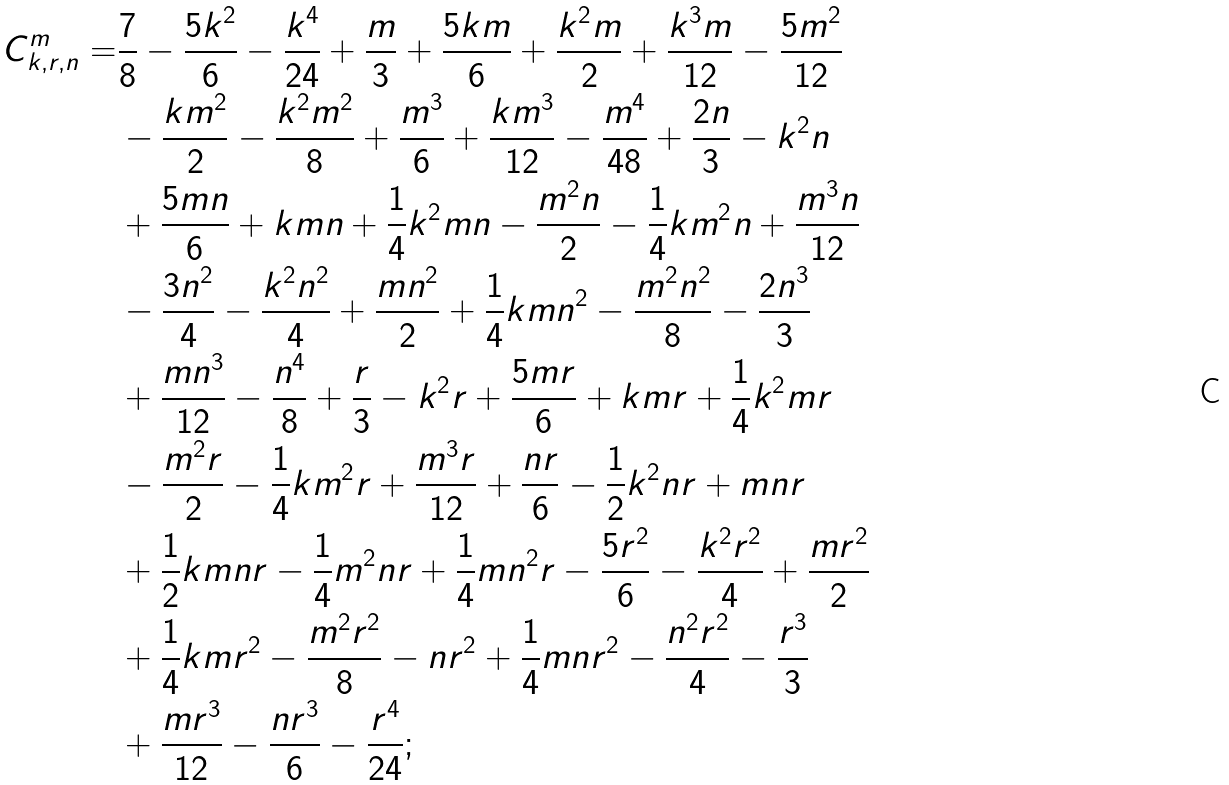<formula> <loc_0><loc_0><loc_500><loc_500>C ^ { m } _ { k , r , n } = & \frac { 7 } { 8 } - \frac { 5 k ^ { 2 } } { 6 } - \frac { k ^ { 4 } } { 2 4 } + \frac { m } { 3 } + \frac { 5 k m } { 6 } + \frac { k ^ { 2 } m } { 2 } + \frac { k ^ { 3 } m } { 1 2 } - \frac { 5 m ^ { 2 } } { 1 2 } \quad \\ & - \frac { k m ^ { 2 } } { 2 } - \frac { k ^ { 2 } m ^ { 2 } } { 8 } + \frac { m ^ { 3 } } { 6 } + \frac { k m ^ { 3 } } { 1 2 } - \frac { m ^ { 4 } } { 4 8 } + \frac { 2 n } { 3 } - k ^ { 2 } n \\ & + \frac { 5 m n } { 6 } + k m n + \frac { 1 } { 4 } k ^ { 2 } m n - \frac { m ^ { 2 } n } { 2 } - \frac { 1 } { 4 } k m ^ { 2 } n + \frac { m ^ { 3 } n } { 1 2 } \\ & - \frac { 3 n ^ { 2 } } { 4 } - \frac { k ^ { 2 } n ^ { 2 } } { 4 } + \frac { m n ^ { 2 } } { 2 } + \frac { 1 } { 4 } k m n ^ { 2 } - \frac { m ^ { 2 } n ^ { 2 } } { 8 } - \frac { 2 n ^ { 3 } } { 3 } \\ & + \frac { m n ^ { 3 } } { 1 2 } - \frac { n ^ { 4 } } { 8 } + \frac { r } { 3 } - k ^ { 2 } r + \frac { 5 m r } { 6 } + k m r + \frac { 1 } { 4 } k ^ { 2 } m r \\ & - \frac { m ^ { 2 } r } { 2 } - \frac { 1 } { 4 } k m ^ { 2 } r + \frac { m ^ { 3 } r } { 1 2 } + \frac { n r } { 6 } - \frac { 1 } { 2 } k ^ { 2 } n r + m n r \\ & + \frac { 1 } { 2 } k m n r - \frac { 1 } { 4 } m ^ { 2 } n r + \frac { 1 } { 4 } m n ^ { 2 } r - \frac { 5 r ^ { 2 } } { 6 } - \frac { k ^ { 2 } r ^ { 2 } } { 4 } + \frac { m r ^ { 2 } } { 2 } \\ & + \frac { 1 } { 4 } k m r ^ { 2 } - \frac { m ^ { 2 } r ^ { 2 } } { 8 } - n r ^ { 2 } + \frac { 1 } { 4 } m n r ^ { 2 } - \frac { n ^ { 2 } r ^ { 2 } } { 4 } - \frac { r ^ { 3 } } { 3 } \\ & + \frac { m r ^ { 3 } } { 1 2 } - \frac { n r ^ { 3 } } { 6 } - \frac { r ^ { 4 } } { 2 4 } ;</formula> 